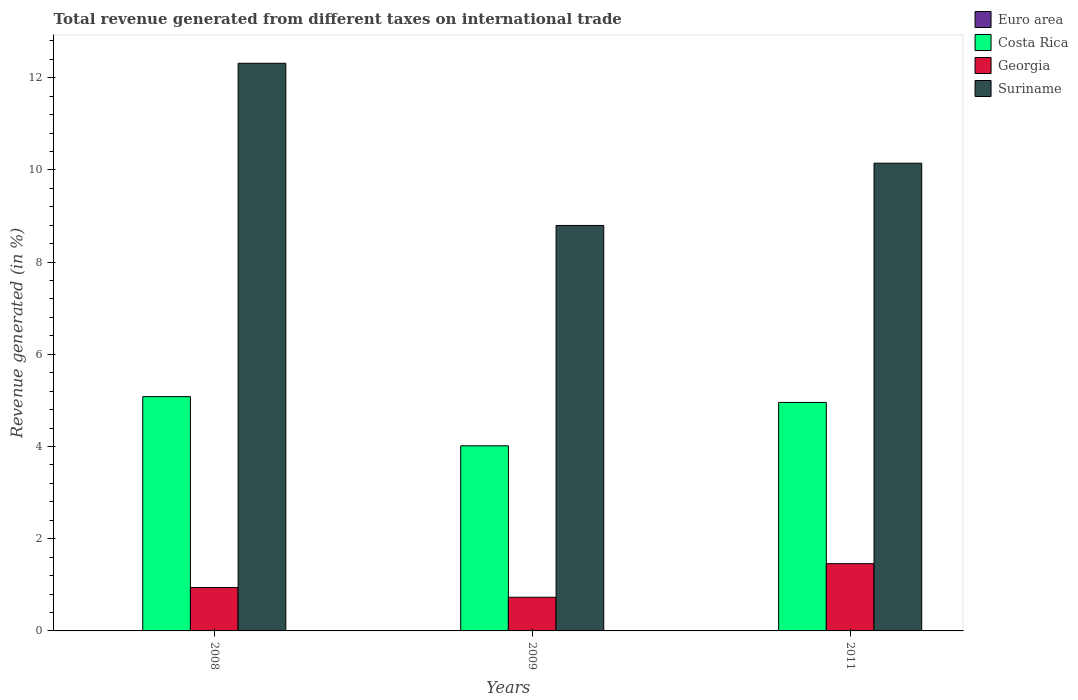How many groups of bars are there?
Give a very brief answer. 3. How many bars are there on the 1st tick from the right?
Give a very brief answer. 4. What is the label of the 2nd group of bars from the left?
Your response must be concise. 2009. What is the total revenue generated in Suriname in 2008?
Keep it short and to the point. 12.31. Across all years, what is the maximum total revenue generated in Costa Rica?
Your response must be concise. 5.08. Across all years, what is the minimum total revenue generated in Euro area?
Your response must be concise. 0. In which year was the total revenue generated in Georgia maximum?
Give a very brief answer. 2011. What is the total total revenue generated in Costa Rica in the graph?
Your answer should be compact. 14.05. What is the difference between the total revenue generated in Suriname in 2008 and that in 2009?
Make the answer very short. 3.52. What is the difference between the total revenue generated in Suriname in 2008 and the total revenue generated in Euro area in 2009?
Offer a terse response. 12.31. What is the average total revenue generated in Costa Rica per year?
Ensure brevity in your answer.  4.68. In the year 2009, what is the difference between the total revenue generated in Costa Rica and total revenue generated in Euro area?
Your response must be concise. 4.01. In how many years, is the total revenue generated in Euro area greater than 6.8 %?
Make the answer very short. 0. What is the ratio of the total revenue generated in Costa Rica in 2009 to that in 2011?
Make the answer very short. 0.81. Is the difference between the total revenue generated in Costa Rica in 2008 and 2009 greater than the difference between the total revenue generated in Euro area in 2008 and 2009?
Give a very brief answer. Yes. What is the difference between the highest and the second highest total revenue generated in Suriname?
Make the answer very short. 2.17. What is the difference between the highest and the lowest total revenue generated in Euro area?
Your answer should be compact. 0. In how many years, is the total revenue generated in Costa Rica greater than the average total revenue generated in Costa Rica taken over all years?
Offer a terse response. 2. Is the sum of the total revenue generated in Costa Rica in 2008 and 2009 greater than the maximum total revenue generated in Suriname across all years?
Your response must be concise. No. Is it the case that in every year, the sum of the total revenue generated in Georgia and total revenue generated in Costa Rica is greater than the sum of total revenue generated in Suriname and total revenue generated in Euro area?
Offer a terse response. Yes. What does the 3rd bar from the left in 2011 represents?
Your answer should be very brief. Georgia. What does the 1st bar from the right in 2011 represents?
Your answer should be very brief. Suriname. How many bars are there?
Your answer should be compact. 12. Are all the bars in the graph horizontal?
Provide a short and direct response. No. How many years are there in the graph?
Your answer should be compact. 3. What is the difference between two consecutive major ticks on the Y-axis?
Ensure brevity in your answer.  2. Are the values on the major ticks of Y-axis written in scientific E-notation?
Ensure brevity in your answer.  No. Does the graph contain any zero values?
Make the answer very short. No. What is the title of the graph?
Make the answer very short. Total revenue generated from different taxes on international trade. Does "High income" appear as one of the legend labels in the graph?
Give a very brief answer. No. What is the label or title of the X-axis?
Give a very brief answer. Years. What is the label or title of the Y-axis?
Your answer should be very brief. Revenue generated (in %). What is the Revenue generated (in %) in Euro area in 2008?
Your answer should be compact. 0. What is the Revenue generated (in %) in Costa Rica in 2008?
Make the answer very short. 5.08. What is the Revenue generated (in %) in Georgia in 2008?
Offer a terse response. 0.94. What is the Revenue generated (in %) of Suriname in 2008?
Offer a very short reply. 12.31. What is the Revenue generated (in %) of Euro area in 2009?
Your response must be concise. 0. What is the Revenue generated (in %) in Costa Rica in 2009?
Keep it short and to the point. 4.02. What is the Revenue generated (in %) in Georgia in 2009?
Offer a very short reply. 0.73. What is the Revenue generated (in %) of Suriname in 2009?
Offer a very short reply. 8.79. What is the Revenue generated (in %) in Euro area in 2011?
Your response must be concise. 0. What is the Revenue generated (in %) of Costa Rica in 2011?
Keep it short and to the point. 4.96. What is the Revenue generated (in %) in Georgia in 2011?
Make the answer very short. 1.46. What is the Revenue generated (in %) of Suriname in 2011?
Your answer should be very brief. 10.15. Across all years, what is the maximum Revenue generated (in %) of Euro area?
Your answer should be very brief. 0. Across all years, what is the maximum Revenue generated (in %) of Costa Rica?
Your response must be concise. 5.08. Across all years, what is the maximum Revenue generated (in %) of Georgia?
Offer a very short reply. 1.46. Across all years, what is the maximum Revenue generated (in %) of Suriname?
Your response must be concise. 12.31. Across all years, what is the minimum Revenue generated (in %) in Euro area?
Provide a succinct answer. 0. Across all years, what is the minimum Revenue generated (in %) of Costa Rica?
Give a very brief answer. 4.02. Across all years, what is the minimum Revenue generated (in %) of Georgia?
Keep it short and to the point. 0.73. Across all years, what is the minimum Revenue generated (in %) in Suriname?
Provide a short and direct response. 8.79. What is the total Revenue generated (in %) in Euro area in the graph?
Provide a short and direct response. 0.01. What is the total Revenue generated (in %) of Costa Rica in the graph?
Your answer should be very brief. 14.05. What is the total Revenue generated (in %) of Georgia in the graph?
Your answer should be very brief. 3.13. What is the total Revenue generated (in %) in Suriname in the graph?
Provide a short and direct response. 31.25. What is the difference between the Revenue generated (in %) in Euro area in 2008 and that in 2009?
Your answer should be compact. 0. What is the difference between the Revenue generated (in %) in Costa Rica in 2008 and that in 2009?
Your answer should be very brief. 1.07. What is the difference between the Revenue generated (in %) in Georgia in 2008 and that in 2009?
Your response must be concise. 0.21. What is the difference between the Revenue generated (in %) of Suriname in 2008 and that in 2009?
Keep it short and to the point. 3.52. What is the difference between the Revenue generated (in %) in Euro area in 2008 and that in 2011?
Provide a short and direct response. -0. What is the difference between the Revenue generated (in %) in Costa Rica in 2008 and that in 2011?
Keep it short and to the point. 0.13. What is the difference between the Revenue generated (in %) in Georgia in 2008 and that in 2011?
Your answer should be compact. -0.52. What is the difference between the Revenue generated (in %) in Suriname in 2008 and that in 2011?
Your answer should be compact. 2.17. What is the difference between the Revenue generated (in %) in Euro area in 2009 and that in 2011?
Offer a terse response. -0. What is the difference between the Revenue generated (in %) of Costa Rica in 2009 and that in 2011?
Offer a very short reply. -0.94. What is the difference between the Revenue generated (in %) of Georgia in 2009 and that in 2011?
Keep it short and to the point. -0.73. What is the difference between the Revenue generated (in %) of Suriname in 2009 and that in 2011?
Your answer should be compact. -1.35. What is the difference between the Revenue generated (in %) of Euro area in 2008 and the Revenue generated (in %) of Costa Rica in 2009?
Ensure brevity in your answer.  -4.01. What is the difference between the Revenue generated (in %) in Euro area in 2008 and the Revenue generated (in %) in Georgia in 2009?
Provide a short and direct response. -0.73. What is the difference between the Revenue generated (in %) of Euro area in 2008 and the Revenue generated (in %) of Suriname in 2009?
Provide a short and direct response. -8.79. What is the difference between the Revenue generated (in %) in Costa Rica in 2008 and the Revenue generated (in %) in Georgia in 2009?
Your answer should be very brief. 4.35. What is the difference between the Revenue generated (in %) of Costa Rica in 2008 and the Revenue generated (in %) of Suriname in 2009?
Give a very brief answer. -3.71. What is the difference between the Revenue generated (in %) of Georgia in 2008 and the Revenue generated (in %) of Suriname in 2009?
Give a very brief answer. -7.85. What is the difference between the Revenue generated (in %) of Euro area in 2008 and the Revenue generated (in %) of Costa Rica in 2011?
Give a very brief answer. -4.95. What is the difference between the Revenue generated (in %) in Euro area in 2008 and the Revenue generated (in %) in Georgia in 2011?
Offer a very short reply. -1.46. What is the difference between the Revenue generated (in %) in Euro area in 2008 and the Revenue generated (in %) in Suriname in 2011?
Make the answer very short. -10.14. What is the difference between the Revenue generated (in %) in Costa Rica in 2008 and the Revenue generated (in %) in Georgia in 2011?
Your answer should be compact. 3.62. What is the difference between the Revenue generated (in %) in Costa Rica in 2008 and the Revenue generated (in %) in Suriname in 2011?
Provide a short and direct response. -5.06. What is the difference between the Revenue generated (in %) in Georgia in 2008 and the Revenue generated (in %) in Suriname in 2011?
Offer a very short reply. -9.21. What is the difference between the Revenue generated (in %) in Euro area in 2009 and the Revenue generated (in %) in Costa Rica in 2011?
Give a very brief answer. -4.95. What is the difference between the Revenue generated (in %) in Euro area in 2009 and the Revenue generated (in %) in Georgia in 2011?
Your answer should be compact. -1.46. What is the difference between the Revenue generated (in %) in Euro area in 2009 and the Revenue generated (in %) in Suriname in 2011?
Ensure brevity in your answer.  -10.14. What is the difference between the Revenue generated (in %) of Costa Rica in 2009 and the Revenue generated (in %) of Georgia in 2011?
Your answer should be very brief. 2.56. What is the difference between the Revenue generated (in %) in Costa Rica in 2009 and the Revenue generated (in %) in Suriname in 2011?
Give a very brief answer. -6.13. What is the difference between the Revenue generated (in %) of Georgia in 2009 and the Revenue generated (in %) of Suriname in 2011?
Provide a short and direct response. -9.42. What is the average Revenue generated (in %) of Euro area per year?
Your response must be concise. 0. What is the average Revenue generated (in %) in Costa Rica per year?
Make the answer very short. 4.68. What is the average Revenue generated (in %) of Georgia per year?
Offer a terse response. 1.04. What is the average Revenue generated (in %) of Suriname per year?
Your answer should be compact. 10.42. In the year 2008, what is the difference between the Revenue generated (in %) in Euro area and Revenue generated (in %) in Costa Rica?
Your answer should be very brief. -5.08. In the year 2008, what is the difference between the Revenue generated (in %) in Euro area and Revenue generated (in %) in Georgia?
Your response must be concise. -0.94. In the year 2008, what is the difference between the Revenue generated (in %) of Euro area and Revenue generated (in %) of Suriname?
Your answer should be compact. -12.31. In the year 2008, what is the difference between the Revenue generated (in %) of Costa Rica and Revenue generated (in %) of Georgia?
Provide a succinct answer. 4.14. In the year 2008, what is the difference between the Revenue generated (in %) in Costa Rica and Revenue generated (in %) in Suriname?
Make the answer very short. -7.23. In the year 2008, what is the difference between the Revenue generated (in %) of Georgia and Revenue generated (in %) of Suriname?
Give a very brief answer. -11.37. In the year 2009, what is the difference between the Revenue generated (in %) of Euro area and Revenue generated (in %) of Costa Rica?
Your answer should be very brief. -4.01. In the year 2009, what is the difference between the Revenue generated (in %) in Euro area and Revenue generated (in %) in Georgia?
Provide a short and direct response. -0.73. In the year 2009, what is the difference between the Revenue generated (in %) in Euro area and Revenue generated (in %) in Suriname?
Your answer should be very brief. -8.79. In the year 2009, what is the difference between the Revenue generated (in %) of Costa Rica and Revenue generated (in %) of Georgia?
Offer a very short reply. 3.29. In the year 2009, what is the difference between the Revenue generated (in %) in Costa Rica and Revenue generated (in %) in Suriname?
Provide a succinct answer. -4.78. In the year 2009, what is the difference between the Revenue generated (in %) of Georgia and Revenue generated (in %) of Suriname?
Your response must be concise. -8.06. In the year 2011, what is the difference between the Revenue generated (in %) in Euro area and Revenue generated (in %) in Costa Rica?
Offer a terse response. -4.95. In the year 2011, what is the difference between the Revenue generated (in %) in Euro area and Revenue generated (in %) in Georgia?
Your answer should be very brief. -1.46. In the year 2011, what is the difference between the Revenue generated (in %) in Euro area and Revenue generated (in %) in Suriname?
Offer a very short reply. -10.14. In the year 2011, what is the difference between the Revenue generated (in %) of Costa Rica and Revenue generated (in %) of Georgia?
Offer a terse response. 3.5. In the year 2011, what is the difference between the Revenue generated (in %) of Costa Rica and Revenue generated (in %) of Suriname?
Make the answer very short. -5.19. In the year 2011, what is the difference between the Revenue generated (in %) in Georgia and Revenue generated (in %) in Suriname?
Provide a short and direct response. -8.69. What is the ratio of the Revenue generated (in %) in Euro area in 2008 to that in 2009?
Offer a terse response. 1.3. What is the ratio of the Revenue generated (in %) of Costa Rica in 2008 to that in 2009?
Offer a terse response. 1.27. What is the ratio of the Revenue generated (in %) in Georgia in 2008 to that in 2009?
Provide a succinct answer. 1.29. What is the ratio of the Revenue generated (in %) of Suriname in 2008 to that in 2009?
Your response must be concise. 1.4. What is the ratio of the Revenue generated (in %) in Euro area in 2008 to that in 2011?
Offer a very short reply. 0.93. What is the ratio of the Revenue generated (in %) in Costa Rica in 2008 to that in 2011?
Keep it short and to the point. 1.03. What is the ratio of the Revenue generated (in %) in Georgia in 2008 to that in 2011?
Your answer should be compact. 0.64. What is the ratio of the Revenue generated (in %) in Suriname in 2008 to that in 2011?
Offer a very short reply. 1.21. What is the ratio of the Revenue generated (in %) in Euro area in 2009 to that in 2011?
Offer a very short reply. 0.72. What is the ratio of the Revenue generated (in %) of Costa Rica in 2009 to that in 2011?
Give a very brief answer. 0.81. What is the ratio of the Revenue generated (in %) of Georgia in 2009 to that in 2011?
Offer a terse response. 0.5. What is the ratio of the Revenue generated (in %) of Suriname in 2009 to that in 2011?
Keep it short and to the point. 0.87. What is the difference between the highest and the second highest Revenue generated (in %) in Costa Rica?
Provide a succinct answer. 0.13. What is the difference between the highest and the second highest Revenue generated (in %) in Georgia?
Your answer should be compact. 0.52. What is the difference between the highest and the second highest Revenue generated (in %) in Suriname?
Offer a very short reply. 2.17. What is the difference between the highest and the lowest Revenue generated (in %) in Euro area?
Offer a very short reply. 0. What is the difference between the highest and the lowest Revenue generated (in %) in Costa Rica?
Offer a terse response. 1.07. What is the difference between the highest and the lowest Revenue generated (in %) in Georgia?
Make the answer very short. 0.73. What is the difference between the highest and the lowest Revenue generated (in %) of Suriname?
Offer a very short reply. 3.52. 